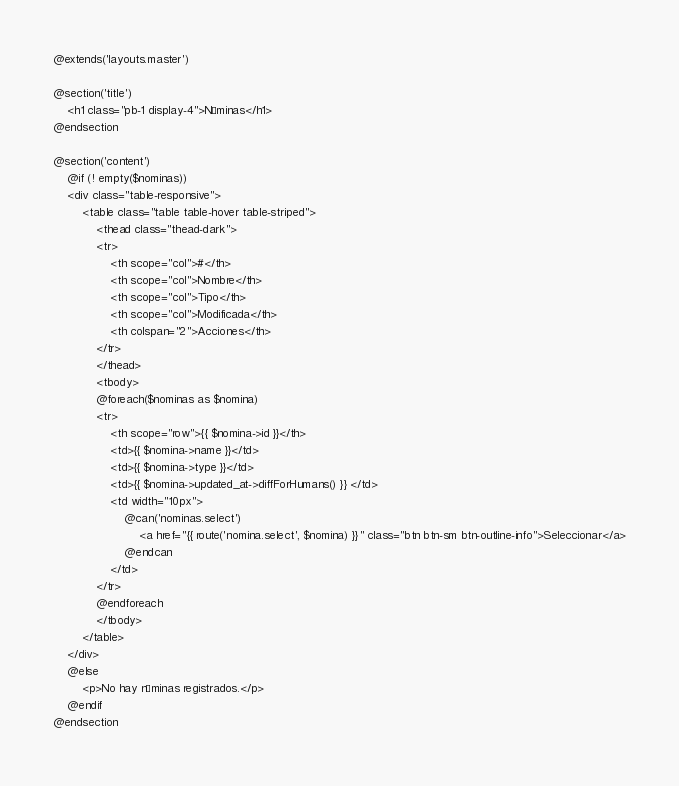Convert code to text. <code><loc_0><loc_0><loc_500><loc_500><_PHP_>@extends('layouts.master')

@section('title')
    <h1 class="pb-1 display-4">Nóminas</h1>
@endsection

@section('content')
    @if (! empty($nominas))
    <div class="table-responsive">
        <table class="table table-hover table-striped">
            <thead class="thead-dark">
            <tr>
                <th scope="col">#</th>
                <th scope="col">Nombre</th>
                <th scope="col">Tipo</th>
                <th scope="col">Modificada</th>
                <th colspan="2">Acciones</th>
            </tr>
            </thead>
            <tbody>
            @foreach($nominas as $nomina)
            <tr>
                <th scope="row">{{ $nomina->id }}</th>
                <td>{{ $nomina->name }}</td>
                <td>{{ $nomina->type }}</td>
                <td>{{ $nomina->updated_at->diffForHumans() }} </td>
                <td width="10px">
                    @can('nominas.select')
                        <a href="{{ route('nomina.select', $nomina) }}" class="btn btn-sm btn-outline-info">Seleccionar</a>
                    @endcan
                </td>
            </tr>
            @endforeach
            </tbody>
        </table>
    </div>
    @else
        <p>No hay nóminas registrados.</p>
    @endif
@endsection</code> 